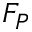Convert formula to latex. <formula><loc_0><loc_0><loc_500><loc_500>F _ { P }</formula> 